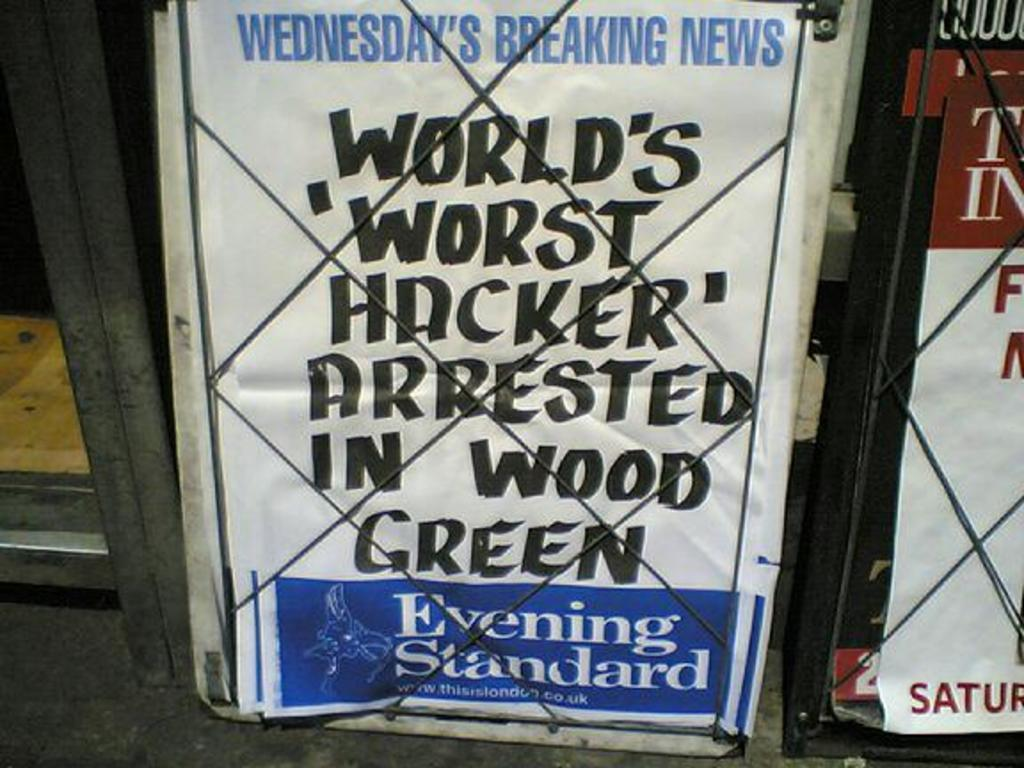<image>
Relay a brief, clear account of the picture shown. The newspaper has the title world's worst hacker. 